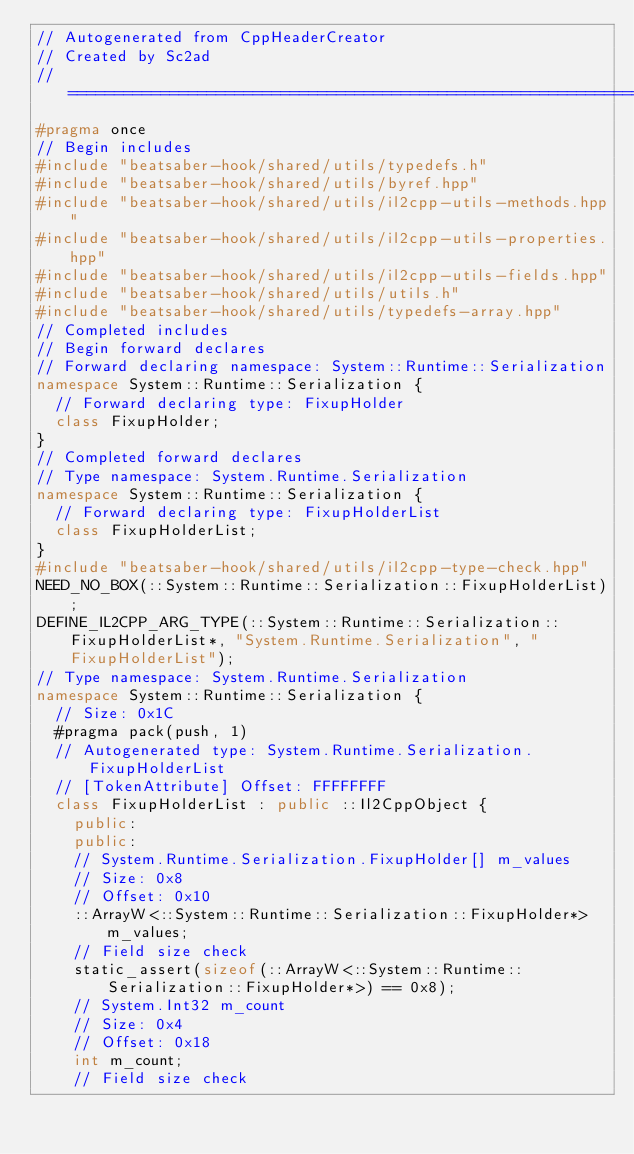<code> <loc_0><loc_0><loc_500><loc_500><_C++_>// Autogenerated from CppHeaderCreator
// Created by Sc2ad
// =========================================================================
#pragma once
// Begin includes
#include "beatsaber-hook/shared/utils/typedefs.h"
#include "beatsaber-hook/shared/utils/byref.hpp"
#include "beatsaber-hook/shared/utils/il2cpp-utils-methods.hpp"
#include "beatsaber-hook/shared/utils/il2cpp-utils-properties.hpp"
#include "beatsaber-hook/shared/utils/il2cpp-utils-fields.hpp"
#include "beatsaber-hook/shared/utils/utils.h"
#include "beatsaber-hook/shared/utils/typedefs-array.hpp"
// Completed includes
// Begin forward declares
// Forward declaring namespace: System::Runtime::Serialization
namespace System::Runtime::Serialization {
  // Forward declaring type: FixupHolder
  class FixupHolder;
}
// Completed forward declares
// Type namespace: System.Runtime.Serialization
namespace System::Runtime::Serialization {
  // Forward declaring type: FixupHolderList
  class FixupHolderList;
}
#include "beatsaber-hook/shared/utils/il2cpp-type-check.hpp"
NEED_NO_BOX(::System::Runtime::Serialization::FixupHolderList);
DEFINE_IL2CPP_ARG_TYPE(::System::Runtime::Serialization::FixupHolderList*, "System.Runtime.Serialization", "FixupHolderList");
// Type namespace: System.Runtime.Serialization
namespace System::Runtime::Serialization {
  // Size: 0x1C
  #pragma pack(push, 1)
  // Autogenerated type: System.Runtime.Serialization.FixupHolderList
  // [TokenAttribute] Offset: FFFFFFFF
  class FixupHolderList : public ::Il2CppObject {
    public:
    public:
    // System.Runtime.Serialization.FixupHolder[] m_values
    // Size: 0x8
    // Offset: 0x10
    ::ArrayW<::System::Runtime::Serialization::FixupHolder*> m_values;
    // Field size check
    static_assert(sizeof(::ArrayW<::System::Runtime::Serialization::FixupHolder*>) == 0x8);
    // System.Int32 m_count
    // Size: 0x4
    // Offset: 0x18
    int m_count;
    // Field size check</code> 